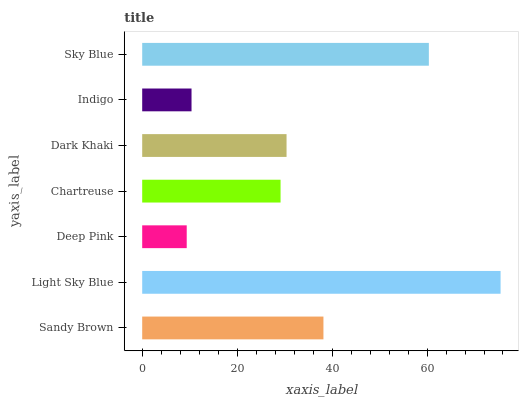Is Deep Pink the minimum?
Answer yes or no. Yes. Is Light Sky Blue the maximum?
Answer yes or no. Yes. Is Light Sky Blue the minimum?
Answer yes or no. No. Is Deep Pink the maximum?
Answer yes or no. No. Is Light Sky Blue greater than Deep Pink?
Answer yes or no. Yes. Is Deep Pink less than Light Sky Blue?
Answer yes or no. Yes. Is Deep Pink greater than Light Sky Blue?
Answer yes or no. No. Is Light Sky Blue less than Deep Pink?
Answer yes or no. No. Is Dark Khaki the high median?
Answer yes or no. Yes. Is Dark Khaki the low median?
Answer yes or no. Yes. Is Sky Blue the high median?
Answer yes or no. No. Is Deep Pink the low median?
Answer yes or no. No. 